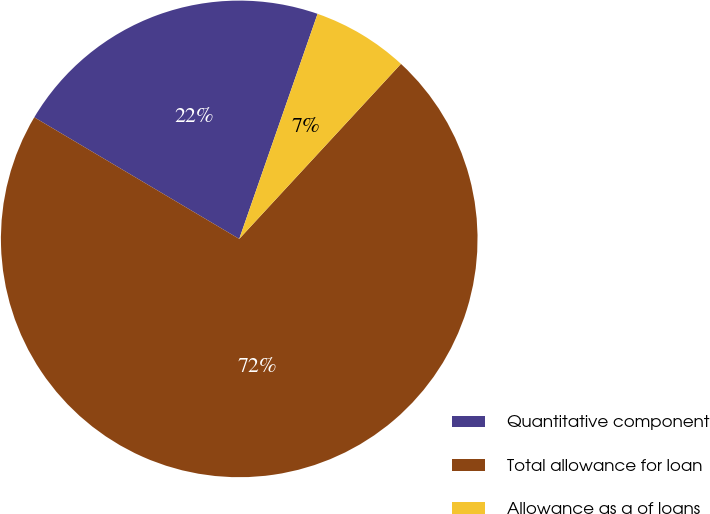<chart> <loc_0><loc_0><loc_500><loc_500><pie_chart><fcel>Quantitative component<fcel>Total allowance for loan<fcel>Allowance as a of loans<nl><fcel>21.81%<fcel>71.65%<fcel>6.54%<nl></chart> 